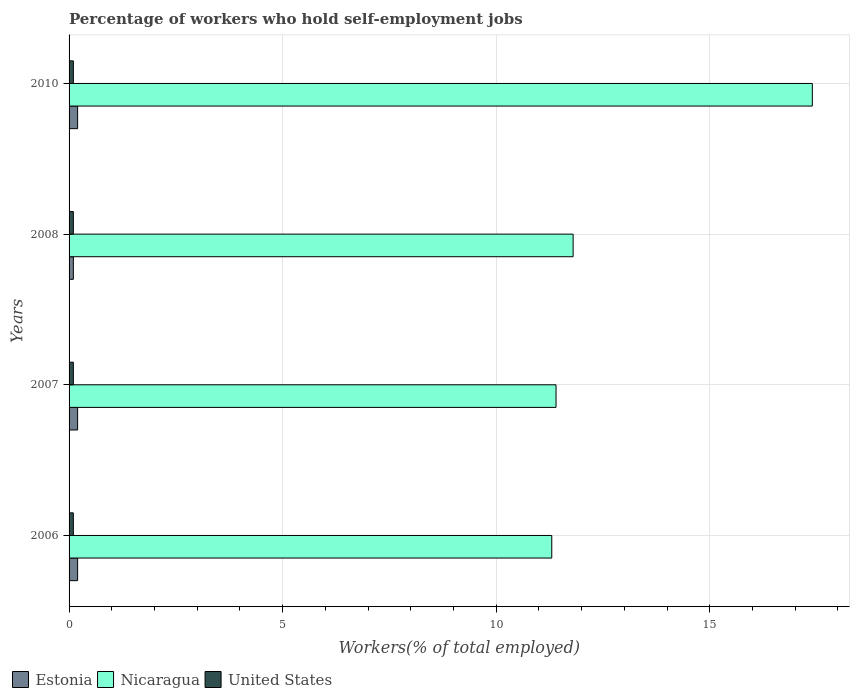How many different coloured bars are there?
Offer a very short reply. 3. Are the number of bars per tick equal to the number of legend labels?
Keep it short and to the point. Yes. Are the number of bars on each tick of the Y-axis equal?
Ensure brevity in your answer.  Yes. How many bars are there on the 4th tick from the top?
Give a very brief answer. 3. How many bars are there on the 4th tick from the bottom?
Provide a succinct answer. 3. In how many cases, is the number of bars for a given year not equal to the number of legend labels?
Your answer should be very brief. 0. What is the percentage of self-employed workers in United States in 2008?
Ensure brevity in your answer.  0.1. Across all years, what is the maximum percentage of self-employed workers in Estonia?
Your answer should be compact. 0.2. Across all years, what is the minimum percentage of self-employed workers in United States?
Give a very brief answer. 0.1. In which year was the percentage of self-employed workers in United States minimum?
Ensure brevity in your answer.  2006. What is the total percentage of self-employed workers in Estonia in the graph?
Keep it short and to the point. 0.7. What is the difference between the percentage of self-employed workers in Estonia in 2006 and that in 2007?
Your response must be concise. 0. What is the difference between the percentage of self-employed workers in United States in 2008 and the percentage of self-employed workers in Estonia in 2007?
Provide a short and direct response. -0.1. What is the average percentage of self-employed workers in Estonia per year?
Offer a very short reply. 0.18. In the year 2008, what is the difference between the percentage of self-employed workers in Estonia and percentage of self-employed workers in Nicaragua?
Provide a short and direct response. -11.7. Is the percentage of self-employed workers in Nicaragua in 2006 less than that in 2007?
Make the answer very short. Yes. What is the difference between the highest and the second highest percentage of self-employed workers in Nicaragua?
Ensure brevity in your answer.  5.6. What is the difference between the highest and the lowest percentage of self-employed workers in Estonia?
Keep it short and to the point. 0.1. In how many years, is the percentage of self-employed workers in Estonia greater than the average percentage of self-employed workers in Estonia taken over all years?
Ensure brevity in your answer.  3. What does the 1st bar from the bottom in 2006 represents?
Offer a terse response. Estonia. How many bars are there?
Your answer should be compact. 12. What is the difference between two consecutive major ticks on the X-axis?
Ensure brevity in your answer.  5. Are the values on the major ticks of X-axis written in scientific E-notation?
Your answer should be very brief. No. Does the graph contain any zero values?
Your response must be concise. No. Does the graph contain grids?
Provide a short and direct response. Yes. Where does the legend appear in the graph?
Make the answer very short. Bottom left. How are the legend labels stacked?
Your answer should be compact. Horizontal. What is the title of the graph?
Offer a very short reply. Percentage of workers who hold self-employment jobs. Does "Swaziland" appear as one of the legend labels in the graph?
Provide a succinct answer. No. What is the label or title of the X-axis?
Keep it short and to the point. Workers(% of total employed). What is the label or title of the Y-axis?
Provide a succinct answer. Years. What is the Workers(% of total employed) of Estonia in 2006?
Ensure brevity in your answer.  0.2. What is the Workers(% of total employed) of Nicaragua in 2006?
Give a very brief answer. 11.3. What is the Workers(% of total employed) in United States in 2006?
Keep it short and to the point. 0.1. What is the Workers(% of total employed) of Estonia in 2007?
Your answer should be compact. 0.2. What is the Workers(% of total employed) of Nicaragua in 2007?
Your answer should be very brief. 11.4. What is the Workers(% of total employed) of United States in 2007?
Your answer should be very brief. 0.1. What is the Workers(% of total employed) of Estonia in 2008?
Offer a terse response. 0.1. What is the Workers(% of total employed) in Nicaragua in 2008?
Your answer should be compact. 11.8. What is the Workers(% of total employed) of United States in 2008?
Offer a very short reply. 0.1. What is the Workers(% of total employed) of Estonia in 2010?
Provide a succinct answer. 0.2. What is the Workers(% of total employed) of Nicaragua in 2010?
Your answer should be compact. 17.4. What is the Workers(% of total employed) in United States in 2010?
Ensure brevity in your answer.  0.1. Across all years, what is the maximum Workers(% of total employed) in Estonia?
Your response must be concise. 0.2. Across all years, what is the maximum Workers(% of total employed) in Nicaragua?
Ensure brevity in your answer.  17.4. Across all years, what is the maximum Workers(% of total employed) in United States?
Give a very brief answer. 0.1. Across all years, what is the minimum Workers(% of total employed) in Estonia?
Your response must be concise. 0.1. Across all years, what is the minimum Workers(% of total employed) of Nicaragua?
Provide a succinct answer. 11.3. Across all years, what is the minimum Workers(% of total employed) of United States?
Offer a terse response. 0.1. What is the total Workers(% of total employed) in Estonia in the graph?
Provide a succinct answer. 0.7. What is the total Workers(% of total employed) of Nicaragua in the graph?
Offer a very short reply. 51.9. What is the difference between the Workers(% of total employed) of United States in 2006 and that in 2007?
Offer a very short reply. 0. What is the difference between the Workers(% of total employed) of Nicaragua in 2006 and that in 2008?
Your answer should be very brief. -0.5. What is the difference between the Workers(% of total employed) in Estonia in 2006 and that in 2010?
Ensure brevity in your answer.  0. What is the difference between the Workers(% of total employed) of Estonia in 2007 and that in 2008?
Give a very brief answer. 0.1. What is the difference between the Workers(% of total employed) in Estonia in 2007 and that in 2010?
Your answer should be very brief. 0. What is the difference between the Workers(% of total employed) of Nicaragua in 2007 and that in 2010?
Make the answer very short. -6. What is the difference between the Workers(% of total employed) in Estonia in 2008 and that in 2010?
Provide a short and direct response. -0.1. What is the difference between the Workers(% of total employed) in Nicaragua in 2008 and that in 2010?
Keep it short and to the point. -5.6. What is the difference between the Workers(% of total employed) in Estonia in 2006 and the Workers(% of total employed) in Nicaragua in 2007?
Provide a short and direct response. -11.2. What is the difference between the Workers(% of total employed) in Nicaragua in 2006 and the Workers(% of total employed) in United States in 2007?
Offer a terse response. 11.2. What is the difference between the Workers(% of total employed) in Nicaragua in 2006 and the Workers(% of total employed) in United States in 2008?
Offer a very short reply. 11.2. What is the difference between the Workers(% of total employed) of Estonia in 2006 and the Workers(% of total employed) of Nicaragua in 2010?
Make the answer very short. -17.2. What is the difference between the Workers(% of total employed) in Estonia in 2006 and the Workers(% of total employed) in United States in 2010?
Offer a very short reply. 0.1. What is the difference between the Workers(% of total employed) of Estonia in 2007 and the Workers(% of total employed) of United States in 2008?
Your answer should be compact. 0.1. What is the difference between the Workers(% of total employed) of Nicaragua in 2007 and the Workers(% of total employed) of United States in 2008?
Your answer should be very brief. 11.3. What is the difference between the Workers(% of total employed) in Estonia in 2007 and the Workers(% of total employed) in Nicaragua in 2010?
Make the answer very short. -17.2. What is the difference between the Workers(% of total employed) of Estonia in 2007 and the Workers(% of total employed) of United States in 2010?
Provide a succinct answer. 0.1. What is the difference between the Workers(% of total employed) of Nicaragua in 2007 and the Workers(% of total employed) of United States in 2010?
Your answer should be compact. 11.3. What is the difference between the Workers(% of total employed) of Estonia in 2008 and the Workers(% of total employed) of Nicaragua in 2010?
Give a very brief answer. -17.3. What is the average Workers(% of total employed) of Estonia per year?
Your answer should be compact. 0.17. What is the average Workers(% of total employed) of Nicaragua per year?
Your response must be concise. 12.97. What is the average Workers(% of total employed) of United States per year?
Your answer should be very brief. 0.1. In the year 2006, what is the difference between the Workers(% of total employed) of Estonia and Workers(% of total employed) of United States?
Make the answer very short. 0.1. In the year 2007, what is the difference between the Workers(% of total employed) of Nicaragua and Workers(% of total employed) of United States?
Your response must be concise. 11.3. In the year 2008, what is the difference between the Workers(% of total employed) of Nicaragua and Workers(% of total employed) of United States?
Provide a succinct answer. 11.7. In the year 2010, what is the difference between the Workers(% of total employed) in Estonia and Workers(% of total employed) in Nicaragua?
Your answer should be very brief. -17.2. What is the ratio of the Workers(% of total employed) in United States in 2006 to that in 2007?
Your answer should be very brief. 1. What is the ratio of the Workers(% of total employed) in Estonia in 2006 to that in 2008?
Your answer should be very brief. 2. What is the ratio of the Workers(% of total employed) of Nicaragua in 2006 to that in 2008?
Give a very brief answer. 0.96. What is the ratio of the Workers(% of total employed) in United States in 2006 to that in 2008?
Provide a short and direct response. 1. What is the ratio of the Workers(% of total employed) in Estonia in 2006 to that in 2010?
Provide a short and direct response. 1. What is the ratio of the Workers(% of total employed) of Nicaragua in 2006 to that in 2010?
Ensure brevity in your answer.  0.65. What is the ratio of the Workers(% of total employed) of United States in 2006 to that in 2010?
Provide a succinct answer. 1. What is the ratio of the Workers(% of total employed) of Nicaragua in 2007 to that in 2008?
Provide a short and direct response. 0.97. What is the ratio of the Workers(% of total employed) of United States in 2007 to that in 2008?
Make the answer very short. 1. What is the ratio of the Workers(% of total employed) in Nicaragua in 2007 to that in 2010?
Give a very brief answer. 0.66. What is the ratio of the Workers(% of total employed) of Estonia in 2008 to that in 2010?
Give a very brief answer. 0.5. What is the ratio of the Workers(% of total employed) in Nicaragua in 2008 to that in 2010?
Keep it short and to the point. 0.68. What is the difference between the highest and the second highest Workers(% of total employed) in Estonia?
Your answer should be very brief. 0. What is the difference between the highest and the second highest Workers(% of total employed) of Nicaragua?
Your response must be concise. 5.6. 